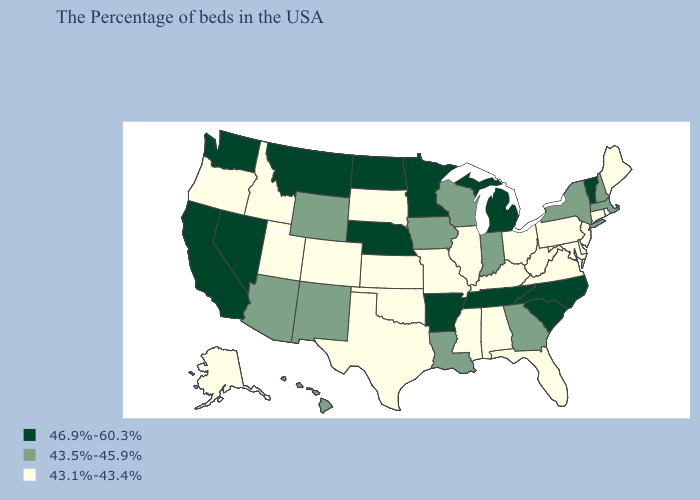Name the states that have a value in the range 43.5%-45.9%?
Answer briefly. Massachusetts, New Hampshire, New York, Georgia, Indiana, Wisconsin, Louisiana, Iowa, Wyoming, New Mexico, Arizona, Hawaii. What is the highest value in states that border New Mexico?
Be succinct. 43.5%-45.9%. What is the value of Missouri?
Give a very brief answer. 43.1%-43.4%. How many symbols are there in the legend?
Short answer required. 3. What is the value of Pennsylvania?
Give a very brief answer. 43.1%-43.4%. Name the states that have a value in the range 43.5%-45.9%?
Give a very brief answer. Massachusetts, New Hampshire, New York, Georgia, Indiana, Wisconsin, Louisiana, Iowa, Wyoming, New Mexico, Arizona, Hawaii. Name the states that have a value in the range 43.1%-43.4%?
Write a very short answer. Maine, Rhode Island, Connecticut, New Jersey, Delaware, Maryland, Pennsylvania, Virginia, West Virginia, Ohio, Florida, Kentucky, Alabama, Illinois, Mississippi, Missouri, Kansas, Oklahoma, Texas, South Dakota, Colorado, Utah, Idaho, Oregon, Alaska. What is the lowest value in the Northeast?
Write a very short answer. 43.1%-43.4%. Does the first symbol in the legend represent the smallest category?
Give a very brief answer. No. Is the legend a continuous bar?
Give a very brief answer. No. Among the states that border New Mexico , does Colorado have the highest value?
Short answer required. No. Among the states that border Louisiana , which have the highest value?
Keep it brief. Arkansas. Does Kentucky have the highest value in the South?
Give a very brief answer. No. Name the states that have a value in the range 46.9%-60.3%?
Answer briefly. Vermont, North Carolina, South Carolina, Michigan, Tennessee, Arkansas, Minnesota, Nebraska, North Dakota, Montana, Nevada, California, Washington. Among the states that border Kentucky , does Tennessee have the highest value?
Short answer required. Yes. 